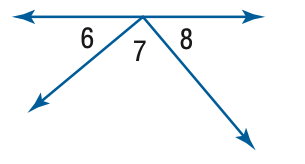Question: \angle 6 and \angle 8 are complementary, m \angle 8 = 47. Find the measure of \angle 6.
Choices:
A. 43
B. 47
C. 86
D. 90
Answer with the letter. Answer: A 